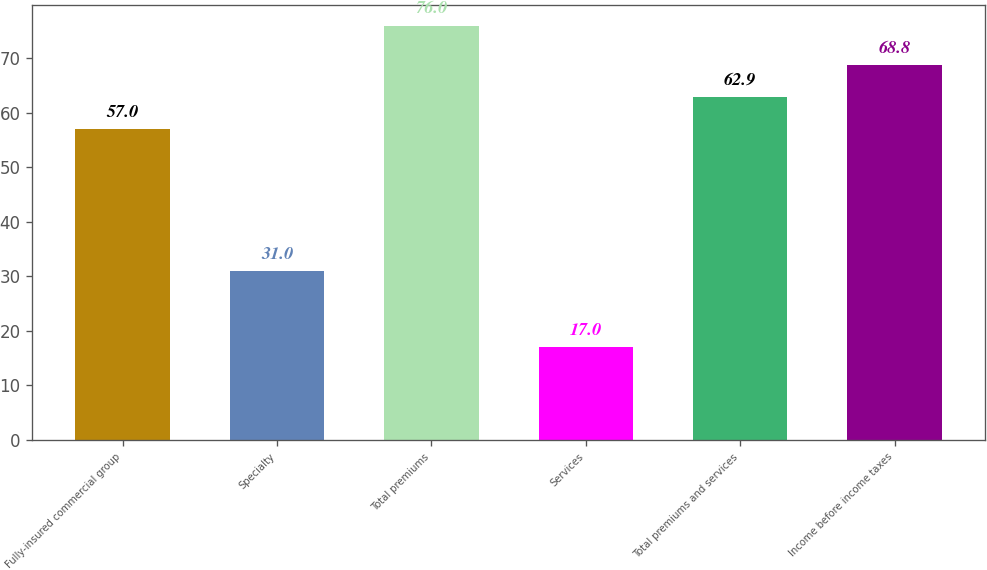Convert chart to OTSL. <chart><loc_0><loc_0><loc_500><loc_500><bar_chart><fcel>Fully-insured commercial group<fcel>Specialty<fcel>Total premiums<fcel>Services<fcel>Total premiums and services<fcel>Income before income taxes<nl><fcel>57<fcel>31<fcel>76<fcel>17<fcel>62.9<fcel>68.8<nl></chart> 